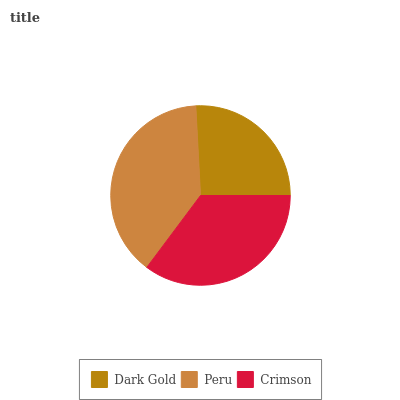Is Dark Gold the minimum?
Answer yes or no. Yes. Is Peru the maximum?
Answer yes or no. Yes. Is Crimson the minimum?
Answer yes or no. No. Is Crimson the maximum?
Answer yes or no. No. Is Peru greater than Crimson?
Answer yes or no. Yes. Is Crimson less than Peru?
Answer yes or no. Yes. Is Crimson greater than Peru?
Answer yes or no. No. Is Peru less than Crimson?
Answer yes or no. No. Is Crimson the high median?
Answer yes or no. Yes. Is Crimson the low median?
Answer yes or no. Yes. Is Dark Gold the high median?
Answer yes or no. No. Is Dark Gold the low median?
Answer yes or no. No. 